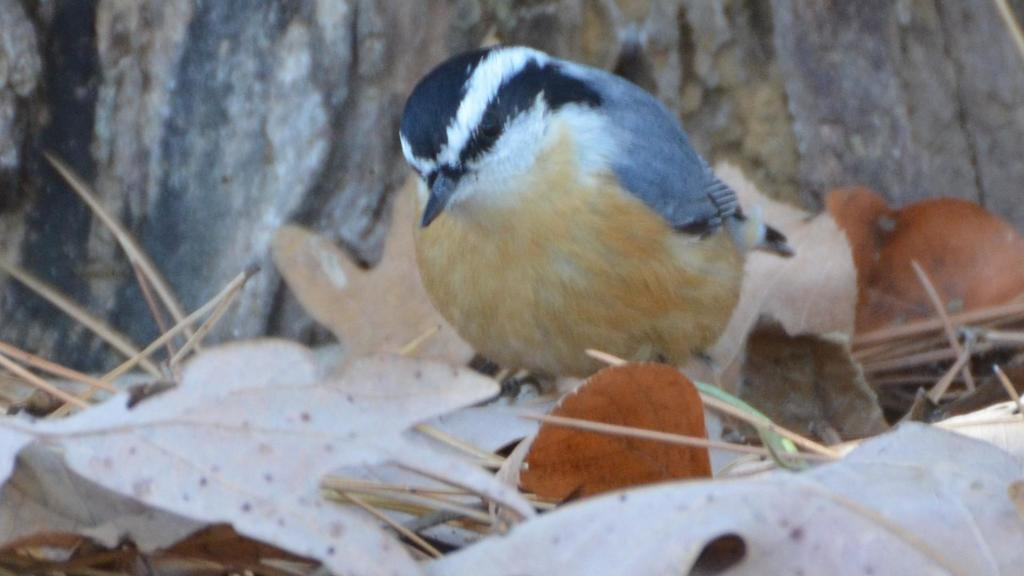What type of animal can be seen in the image? There is a bird in the image. What is the bird sitting on? The bird is on leaves and thorns. What can be seen in the background of the image? There is a wooden trunk visible in the background of the image? What is present at the bottom of the image? Leaves and thorns are present at the bottom of the image. What hobbies does the bird have, as depicted in the image? The image does not provide information about the bird's hobbies. Is there a yak present in the image? No, there is no yak present in the image. 